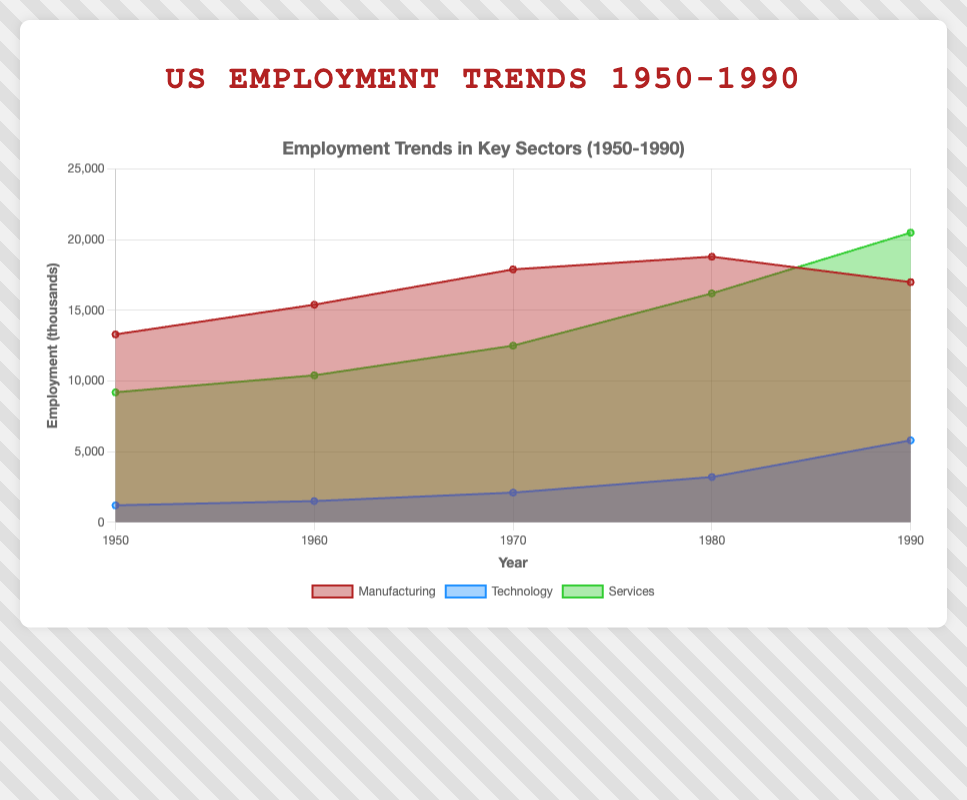What is the title of the figure? Looking at the very top of the figure, the title "US Employment Trends 1950-1990" is clearly displayed.
Answer: US Employment Trends 1950-1990 How many years are presented on the x-axis? The x-axis has tick marks and labels for the years 1950, 1960, 1970, 1980, and 1990. Counting these, we get a total of 5 years.
Answer: 5 Which sector had the highest employment in 1990? By examining the endpoints of the lines in 1990, the Services sector appears to have the highest position on the y-axis at 20500.
Answer: Services What is the general trend in Technology sector employment from 1950 to 1990? Observing the shape and slope of the area for Technology, there is a continuous upward trend, steepening significantly after 1970.
Answer: Increasing What sector shows a decline in employment between 1980 and 1990? By comparing the employment levels for each sector in 1980 and 1990, Manufacturing is the only one that shows a decrease (from 18800 to 17000).
Answer: Manufacturing Between which decades did the Manufacturing sector see the greatest increase in employment? By calculating the differences, the increases are: (1960-1950)=2100, (1970-1960)=2500, (1980-1970)=900, (1990-1980)=-1800. The largest increase was between 1960 and 1970.
Answer: 1960-1970 How does the employment in the Services sector compare to Manufacturing in 1960? Looking at the specific values for 1960, Services stands at 10400 and Manufacturing at 15400. Services has lower employment than Manufacturing in that year.
Answer: Lower What is the total employment across all sectors in 1970? Summing the y-axis values for all three sectors in 1970: Manufacturing (17900) + Technology (2100) + Services (12500) = 32500.
Answer: 32500 By how much did employment in the Technology sector increase from 1950 to 1970? Subtracting the 1950 value from the 1970 value for Technology: 2100 - 1200 = 900.
Answer: 900 Which sector grew the most in absolute terms from 1950 to 1990? Calculating the absolute changes: Manufacturing (17000-13300)=3700, Technology (5800-1200)=4600, Services (20500-9200)=11300. The Services sector grew the most.
Answer: Services 